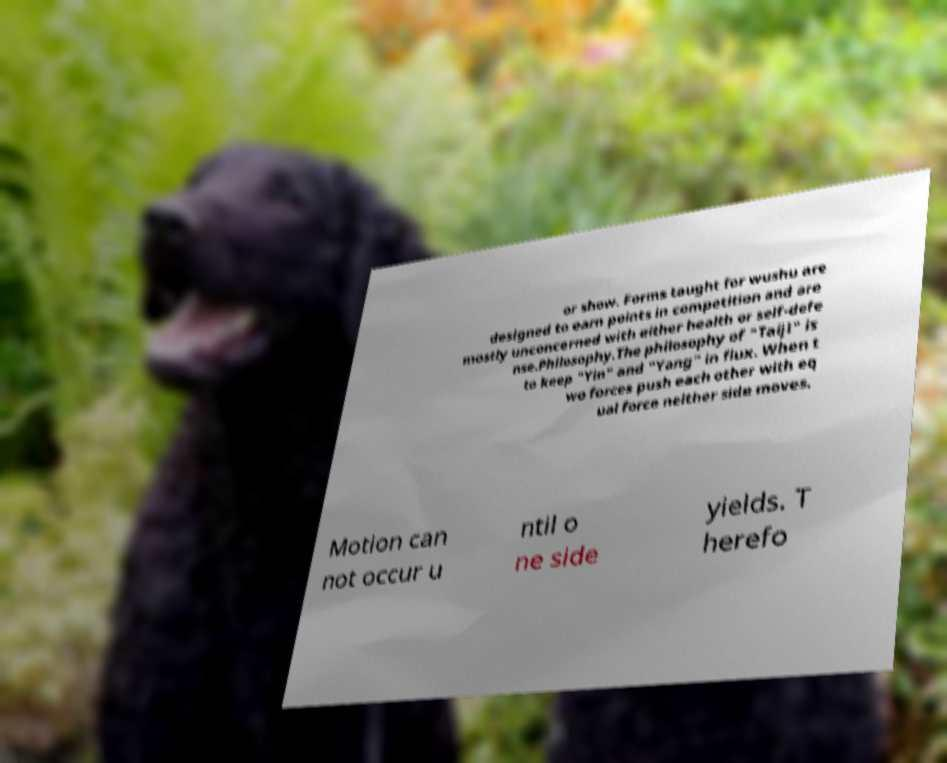Can you read and provide the text displayed in the image?This photo seems to have some interesting text. Can you extract and type it out for me? or show. Forms taught for wushu are designed to earn points in competition and are mostly unconcerned with either health or self-defe nse.Philosophy.The philosophy of "Taiji" is to keep "Yin" and "Yang" in flux. When t wo forces push each other with eq ual force neither side moves. Motion can not occur u ntil o ne side yields. T herefo 